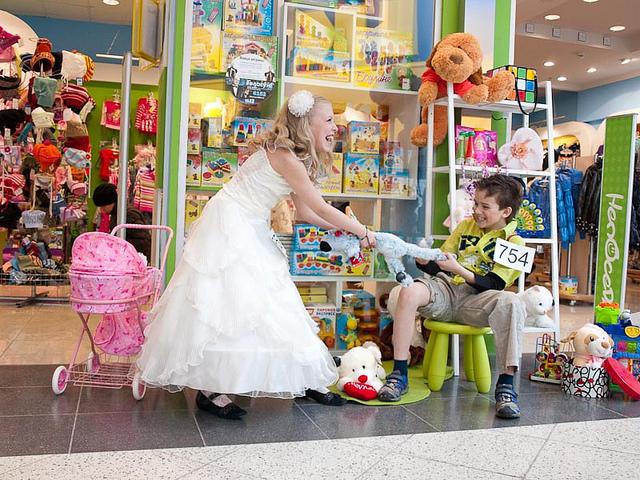Why is the girl so dressed up?
Be succinct. Commercial. Does the boy have a number?
Short answer required. Yes. Is this a toy store?
Quick response, please. Yes. 